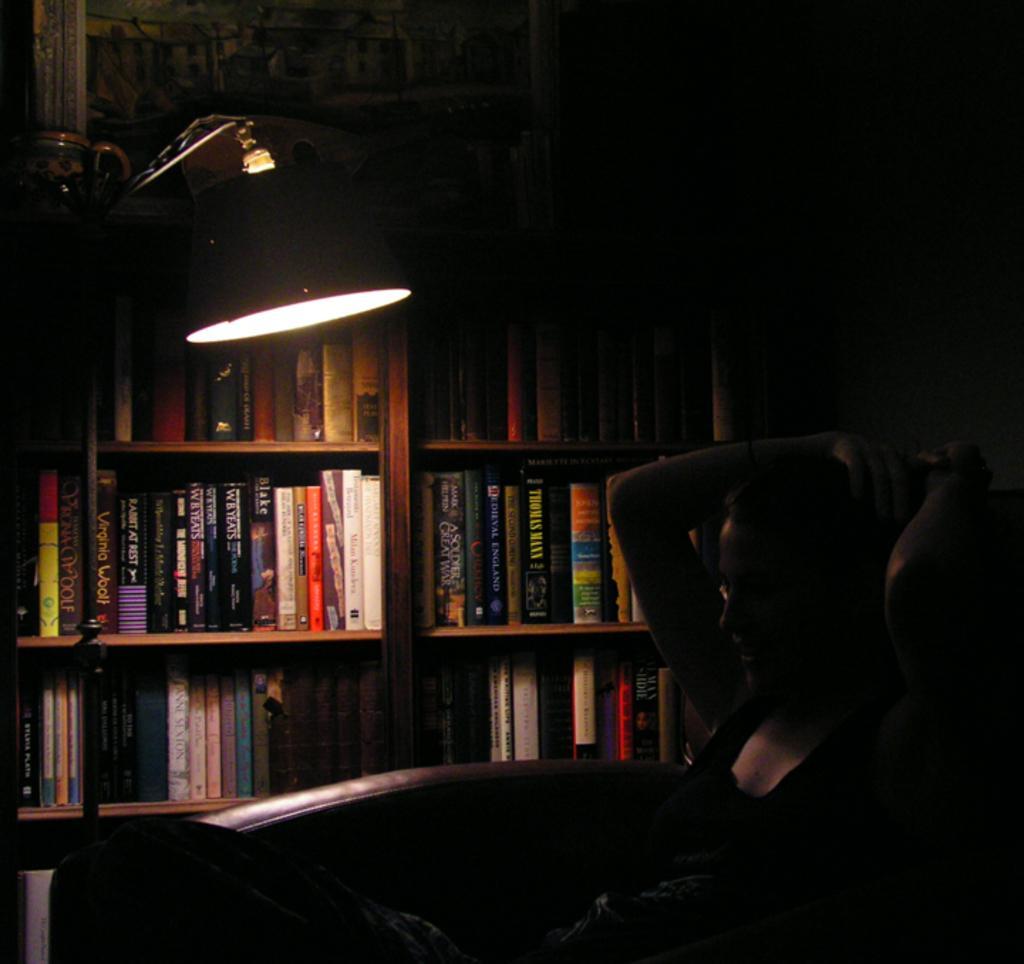Can you describe this image briefly? In this picture we can see a person, lamp, books in racks and in the background it is dark. 